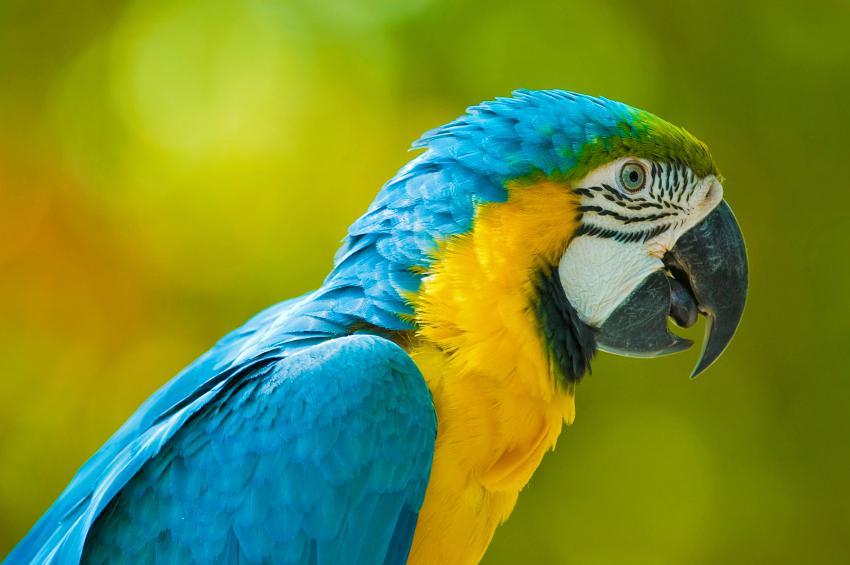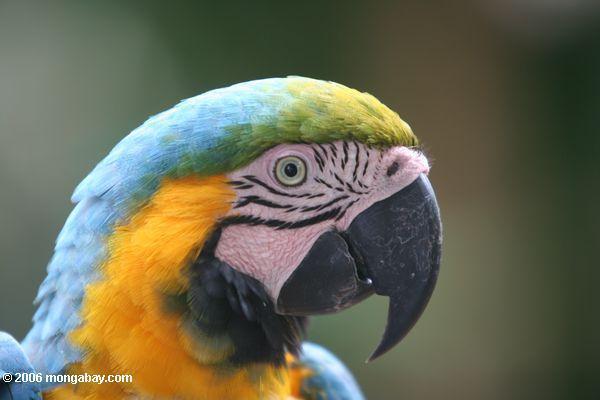The first image is the image on the left, the second image is the image on the right. Analyze the images presented: Is the assertion "There are two birds" valid? Answer yes or no. Yes. 